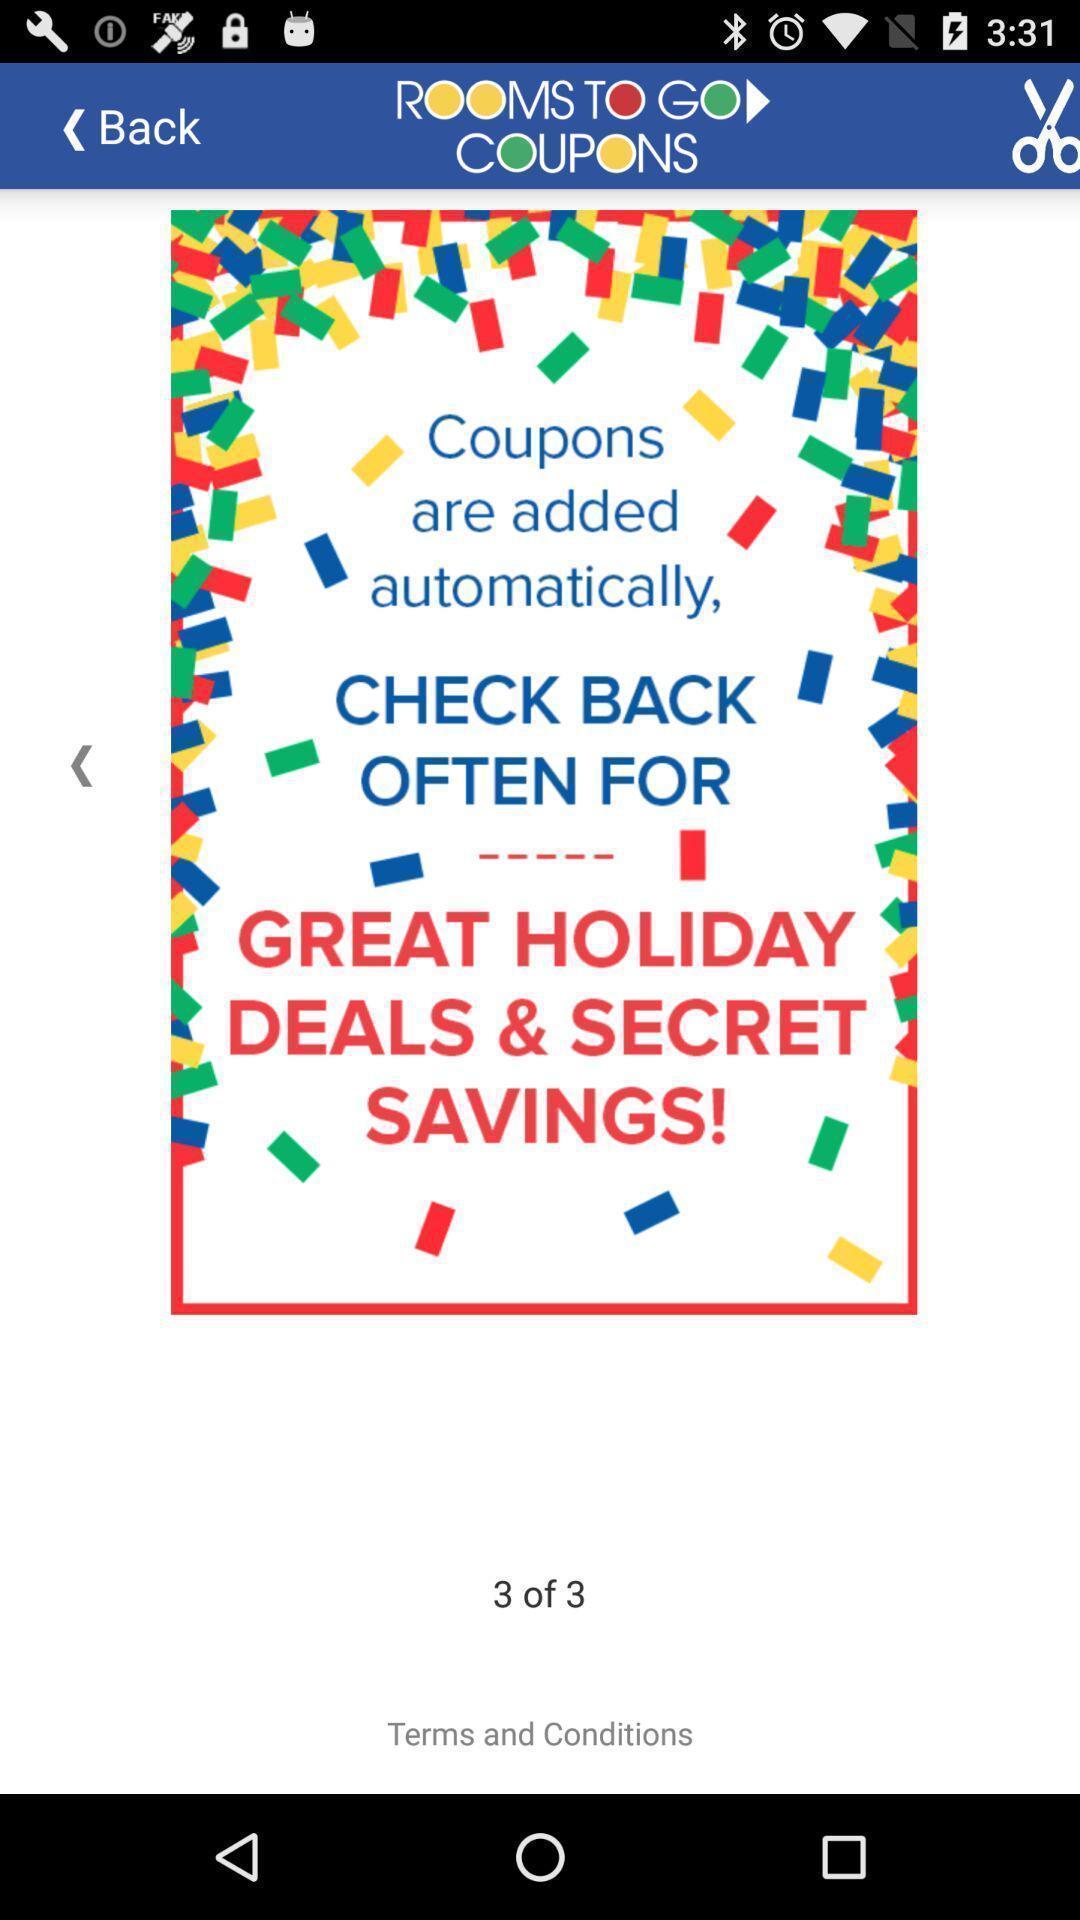Describe this image in words. Screen displaying deals and offers information. 